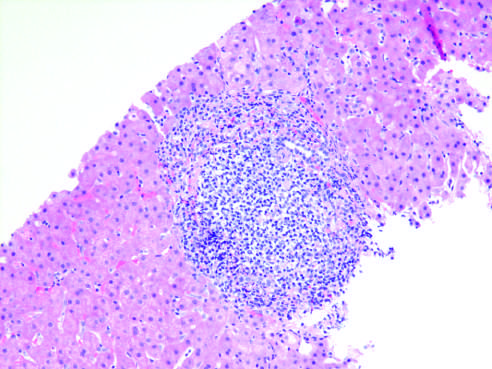does chronic viral hepatitis due to hcv show characteristic portal tract expansion by a dense lymphoid infiltrate?
Answer the question using a single word or phrase. Yes 